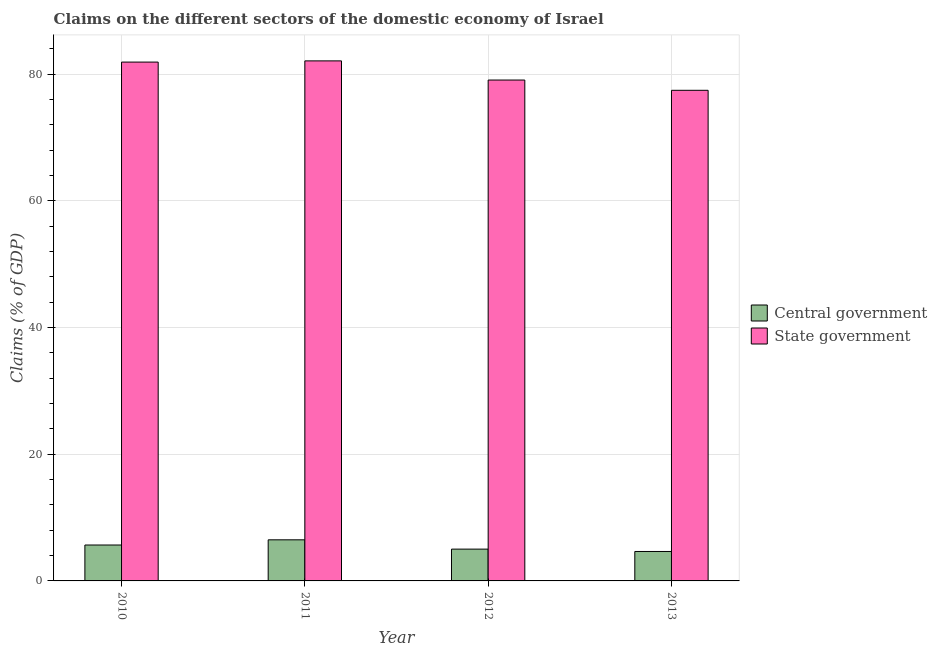How many groups of bars are there?
Provide a succinct answer. 4. How many bars are there on the 3rd tick from the right?
Ensure brevity in your answer.  2. What is the label of the 3rd group of bars from the left?
Offer a terse response. 2012. What is the claims on central government in 2010?
Your response must be concise. 5.67. Across all years, what is the maximum claims on state government?
Give a very brief answer. 82.08. Across all years, what is the minimum claims on central government?
Give a very brief answer. 4.65. In which year was the claims on state government minimum?
Provide a succinct answer. 2013. What is the total claims on central government in the graph?
Your answer should be very brief. 21.82. What is the difference between the claims on central government in 2010 and that in 2013?
Ensure brevity in your answer.  1.02. What is the difference between the claims on central government in 2012 and the claims on state government in 2010?
Offer a very short reply. -0.65. What is the average claims on central government per year?
Your answer should be compact. 5.46. In the year 2010, what is the difference between the claims on central government and claims on state government?
Give a very brief answer. 0. In how many years, is the claims on central government greater than 60 %?
Make the answer very short. 0. What is the ratio of the claims on state government in 2010 to that in 2013?
Keep it short and to the point. 1.06. Is the difference between the claims on central government in 2010 and 2013 greater than the difference between the claims on state government in 2010 and 2013?
Give a very brief answer. No. What is the difference between the highest and the second highest claims on central government?
Provide a short and direct response. 0.82. What is the difference between the highest and the lowest claims on state government?
Give a very brief answer. 4.64. Is the sum of the claims on central government in 2010 and 2013 greater than the maximum claims on state government across all years?
Keep it short and to the point. Yes. What does the 1st bar from the left in 2011 represents?
Give a very brief answer. Central government. What does the 2nd bar from the right in 2012 represents?
Offer a very short reply. Central government. Are all the bars in the graph horizontal?
Your answer should be compact. No. How many years are there in the graph?
Your answer should be compact. 4. Are the values on the major ticks of Y-axis written in scientific E-notation?
Offer a terse response. No. Does the graph contain grids?
Keep it short and to the point. Yes. How many legend labels are there?
Offer a very short reply. 2. What is the title of the graph?
Make the answer very short. Claims on the different sectors of the domestic economy of Israel. What is the label or title of the X-axis?
Give a very brief answer. Year. What is the label or title of the Y-axis?
Offer a very short reply. Claims (% of GDP). What is the Claims (% of GDP) of Central government in 2010?
Give a very brief answer. 5.67. What is the Claims (% of GDP) of State government in 2010?
Give a very brief answer. 81.89. What is the Claims (% of GDP) of Central government in 2011?
Your answer should be compact. 6.49. What is the Claims (% of GDP) in State government in 2011?
Provide a short and direct response. 82.08. What is the Claims (% of GDP) in Central government in 2012?
Your answer should be very brief. 5.02. What is the Claims (% of GDP) in State government in 2012?
Make the answer very short. 79.06. What is the Claims (% of GDP) in Central government in 2013?
Offer a very short reply. 4.65. What is the Claims (% of GDP) in State government in 2013?
Your answer should be very brief. 77.44. Across all years, what is the maximum Claims (% of GDP) of Central government?
Make the answer very short. 6.49. Across all years, what is the maximum Claims (% of GDP) in State government?
Provide a succinct answer. 82.08. Across all years, what is the minimum Claims (% of GDP) in Central government?
Keep it short and to the point. 4.65. Across all years, what is the minimum Claims (% of GDP) of State government?
Your answer should be very brief. 77.44. What is the total Claims (% of GDP) in Central government in the graph?
Your response must be concise. 21.82. What is the total Claims (% of GDP) in State government in the graph?
Ensure brevity in your answer.  320.48. What is the difference between the Claims (% of GDP) of Central government in 2010 and that in 2011?
Offer a very short reply. -0.82. What is the difference between the Claims (% of GDP) of State government in 2010 and that in 2011?
Keep it short and to the point. -0.19. What is the difference between the Claims (% of GDP) of Central government in 2010 and that in 2012?
Offer a terse response. 0.65. What is the difference between the Claims (% of GDP) of State government in 2010 and that in 2012?
Offer a very short reply. 2.83. What is the difference between the Claims (% of GDP) of Central government in 2010 and that in 2013?
Provide a succinct answer. 1.02. What is the difference between the Claims (% of GDP) in State government in 2010 and that in 2013?
Offer a very short reply. 4.45. What is the difference between the Claims (% of GDP) in Central government in 2011 and that in 2012?
Make the answer very short. 1.47. What is the difference between the Claims (% of GDP) in State government in 2011 and that in 2012?
Give a very brief answer. 3.02. What is the difference between the Claims (% of GDP) in Central government in 2011 and that in 2013?
Your answer should be compact. 1.84. What is the difference between the Claims (% of GDP) of State government in 2011 and that in 2013?
Offer a very short reply. 4.64. What is the difference between the Claims (% of GDP) in Central government in 2012 and that in 2013?
Your response must be concise. 0.37. What is the difference between the Claims (% of GDP) of State government in 2012 and that in 2013?
Provide a short and direct response. 1.62. What is the difference between the Claims (% of GDP) in Central government in 2010 and the Claims (% of GDP) in State government in 2011?
Provide a succinct answer. -76.42. What is the difference between the Claims (% of GDP) in Central government in 2010 and the Claims (% of GDP) in State government in 2012?
Offer a terse response. -73.39. What is the difference between the Claims (% of GDP) in Central government in 2010 and the Claims (% of GDP) in State government in 2013?
Keep it short and to the point. -71.77. What is the difference between the Claims (% of GDP) in Central government in 2011 and the Claims (% of GDP) in State government in 2012?
Offer a very short reply. -72.57. What is the difference between the Claims (% of GDP) in Central government in 2011 and the Claims (% of GDP) in State government in 2013?
Your answer should be very brief. -70.95. What is the difference between the Claims (% of GDP) of Central government in 2012 and the Claims (% of GDP) of State government in 2013?
Ensure brevity in your answer.  -72.42. What is the average Claims (% of GDP) in Central government per year?
Provide a succinct answer. 5.46. What is the average Claims (% of GDP) in State government per year?
Offer a very short reply. 80.12. In the year 2010, what is the difference between the Claims (% of GDP) of Central government and Claims (% of GDP) of State government?
Provide a succinct answer. -76.23. In the year 2011, what is the difference between the Claims (% of GDP) in Central government and Claims (% of GDP) in State government?
Ensure brevity in your answer.  -75.6. In the year 2012, what is the difference between the Claims (% of GDP) of Central government and Claims (% of GDP) of State government?
Your answer should be very brief. -74.04. In the year 2013, what is the difference between the Claims (% of GDP) of Central government and Claims (% of GDP) of State government?
Your answer should be compact. -72.79. What is the ratio of the Claims (% of GDP) of Central government in 2010 to that in 2011?
Offer a very short reply. 0.87. What is the ratio of the Claims (% of GDP) of Central government in 2010 to that in 2012?
Provide a succinct answer. 1.13. What is the ratio of the Claims (% of GDP) in State government in 2010 to that in 2012?
Make the answer very short. 1.04. What is the ratio of the Claims (% of GDP) of Central government in 2010 to that in 2013?
Provide a short and direct response. 1.22. What is the ratio of the Claims (% of GDP) in State government in 2010 to that in 2013?
Ensure brevity in your answer.  1.06. What is the ratio of the Claims (% of GDP) of Central government in 2011 to that in 2012?
Give a very brief answer. 1.29. What is the ratio of the Claims (% of GDP) in State government in 2011 to that in 2012?
Make the answer very short. 1.04. What is the ratio of the Claims (% of GDP) in Central government in 2011 to that in 2013?
Ensure brevity in your answer.  1.4. What is the ratio of the Claims (% of GDP) of State government in 2011 to that in 2013?
Provide a succinct answer. 1.06. What is the ratio of the Claims (% of GDP) of Central government in 2012 to that in 2013?
Your response must be concise. 1.08. What is the ratio of the Claims (% of GDP) in State government in 2012 to that in 2013?
Your response must be concise. 1.02. What is the difference between the highest and the second highest Claims (% of GDP) of Central government?
Keep it short and to the point. 0.82. What is the difference between the highest and the second highest Claims (% of GDP) in State government?
Your response must be concise. 0.19. What is the difference between the highest and the lowest Claims (% of GDP) in Central government?
Provide a short and direct response. 1.84. What is the difference between the highest and the lowest Claims (% of GDP) in State government?
Your answer should be compact. 4.64. 